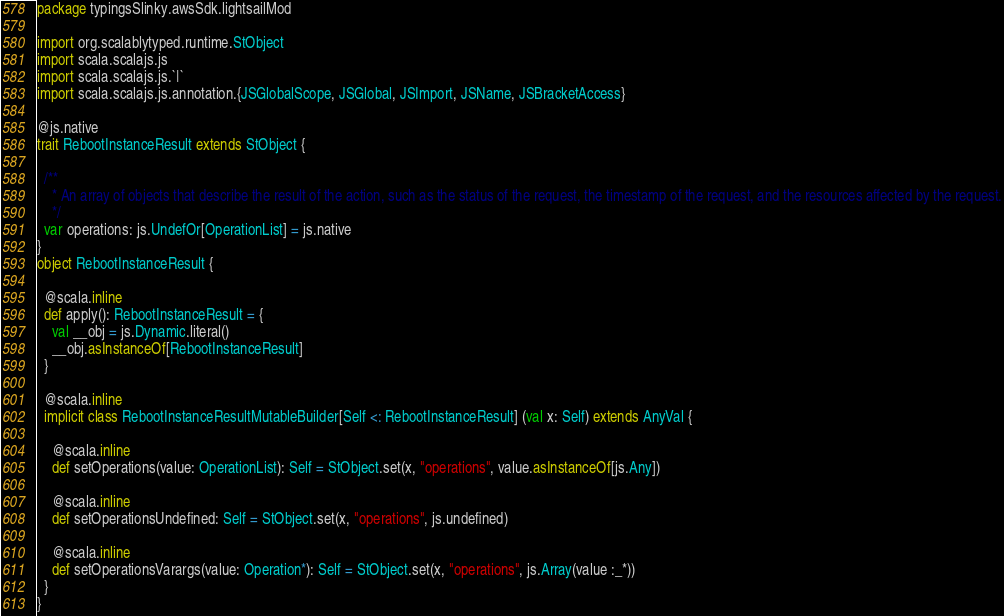Convert code to text. <code><loc_0><loc_0><loc_500><loc_500><_Scala_>package typingsSlinky.awsSdk.lightsailMod

import org.scalablytyped.runtime.StObject
import scala.scalajs.js
import scala.scalajs.js.`|`
import scala.scalajs.js.annotation.{JSGlobalScope, JSGlobal, JSImport, JSName, JSBracketAccess}

@js.native
trait RebootInstanceResult extends StObject {
  
  /**
    * An array of objects that describe the result of the action, such as the status of the request, the timestamp of the request, and the resources affected by the request.
    */
  var operations: js.UndefOr[OperationList] = js.native
}
object RebootInstanceResult {
  
  @scala.inline
  def apply(): RebootInstanceResult = {
    val __obj = js.Dynamic.literal()
    __obj.asInstanceOf[RebootInstanceResult]
  }
  
  @scala.inline
  implicit class RebootInstanceResultMutableBuilder[Self <: RebootInstanceResult] (val x: Self) extends AnyVal {
    
    @scala.inline
    def setOperations(value: OperationList): Self = StObject.set(x, "operations", value.asInstanceOf[js.Any])
    
    @scala.inline
    def setOperationsUndefined: Self = StObject.set(x, "operations", js.undefined)
    
    @scala.inline
    def setOperationsVarargs(value: Operation*): Self = StObject.set(x, "operations", js.Array(value :_*))
  }
}
</code> 